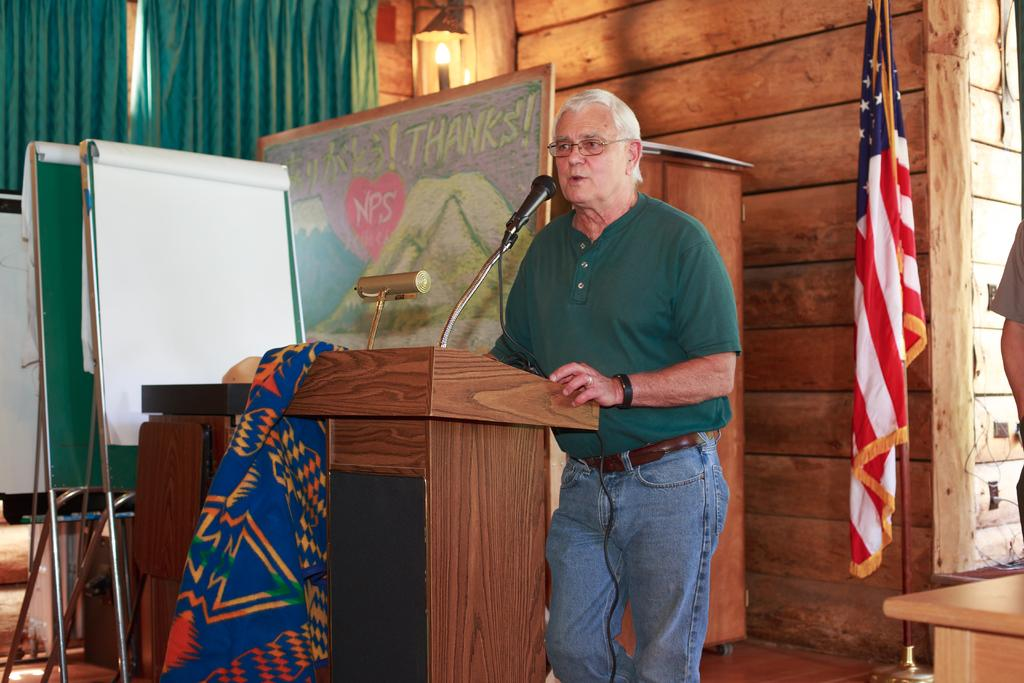What is the person in the image doing? The person is standing at a desk in the image. What object is on the desk? There is a microphone on the desk. What can be seen in the background of the image? There is a flag, at least one person, a wall, a board, a light, and a curtain in the background of the image. What type of island can be seen in the background of the image? There is no island present in the image; it features a person standing at a desk with a microphone and various elements in the background. What kind of branch is the person holding in the image? There is no branch present in the image; the person is standing at a desk with a microphone and various elements in the background. 